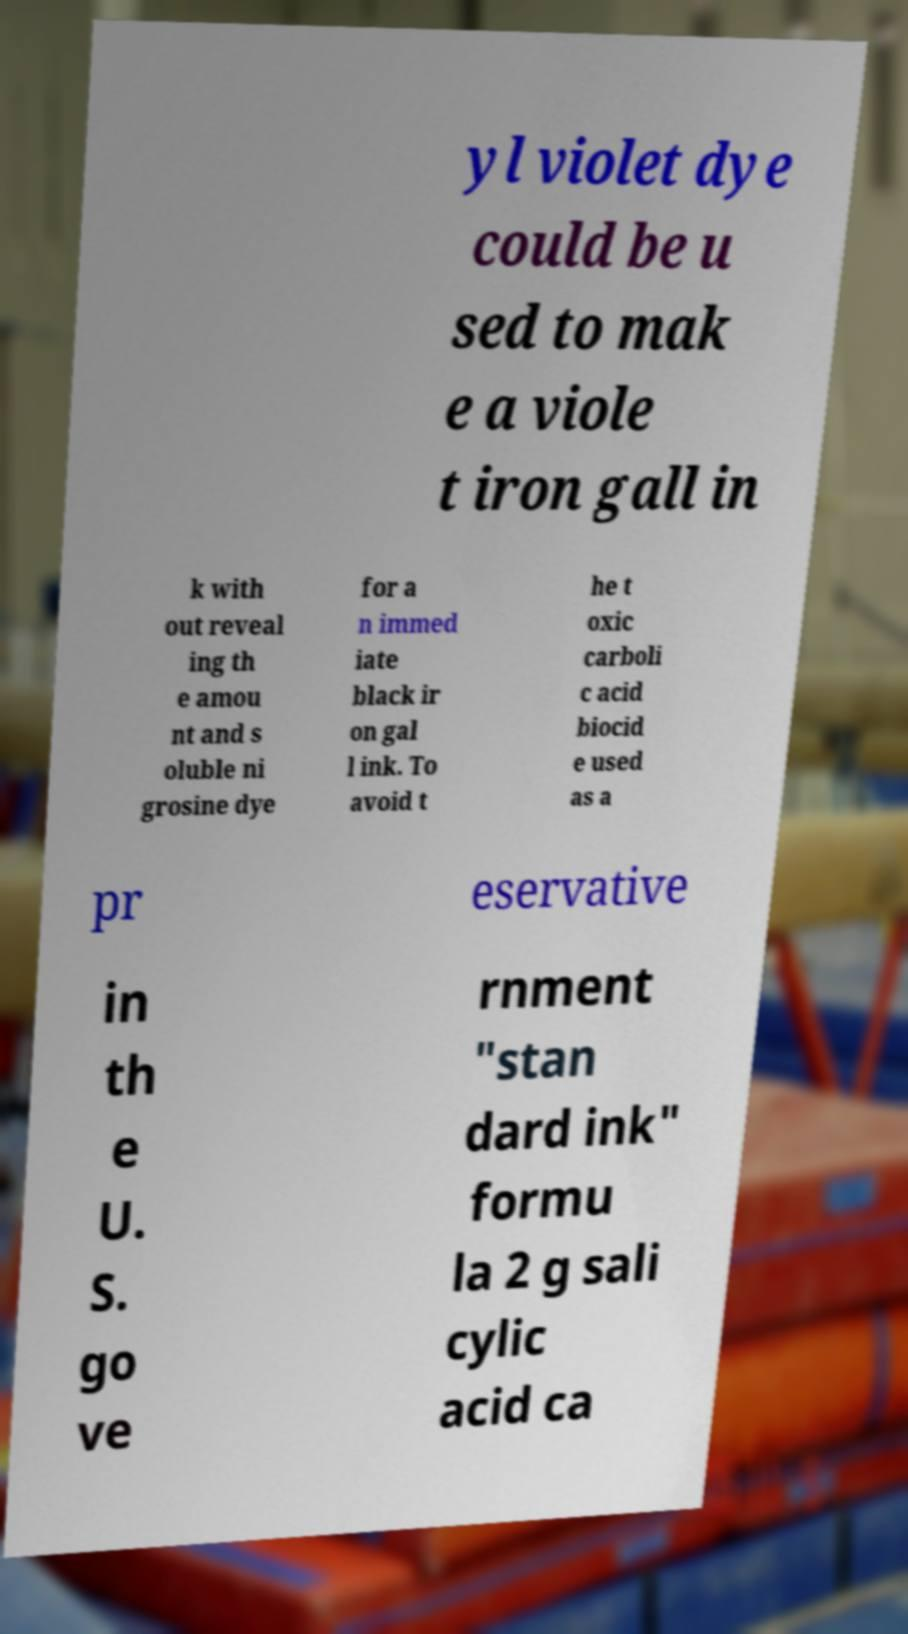Could you assist in decoding the text presented in this image and type it out clearly? yl violet dye could be u sed to mak e a viole t iron gall in k with out reveal ing th e amou nt and s oluble ni grosine dye for a n immed iate black ir on gal l ink. To avoid t he t oxic carboli c acid biocid e used as a pr eservative in th e U. S. go ve rnment "stan dard ink" formu la 2 g sali cylic acid ca 